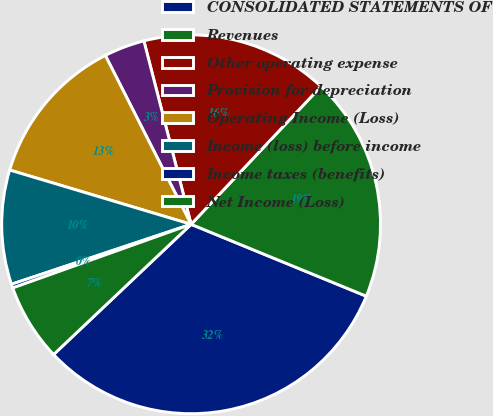<chart> <loc_0><loc_0><loc_500><loc_500><pie_chart><fcel>CONSOLIDATED STATEMENTS OF<fcel>Revenues<fcel>Other operating expense<fcel>Provision for depreciation<fcel>Operating Income (Loss)<fcel>Income (loss) before income<fcel>Income taxes (benefits)<fcel>Net Income (Loss)<nl><fcel>31.73%<fcel>19.17%<fcel>16.03%<fcel>3.47%<fcel>12.89%<fcel>9.75%<fcel>0.33%<fcel>6.61%<nl></chart> 